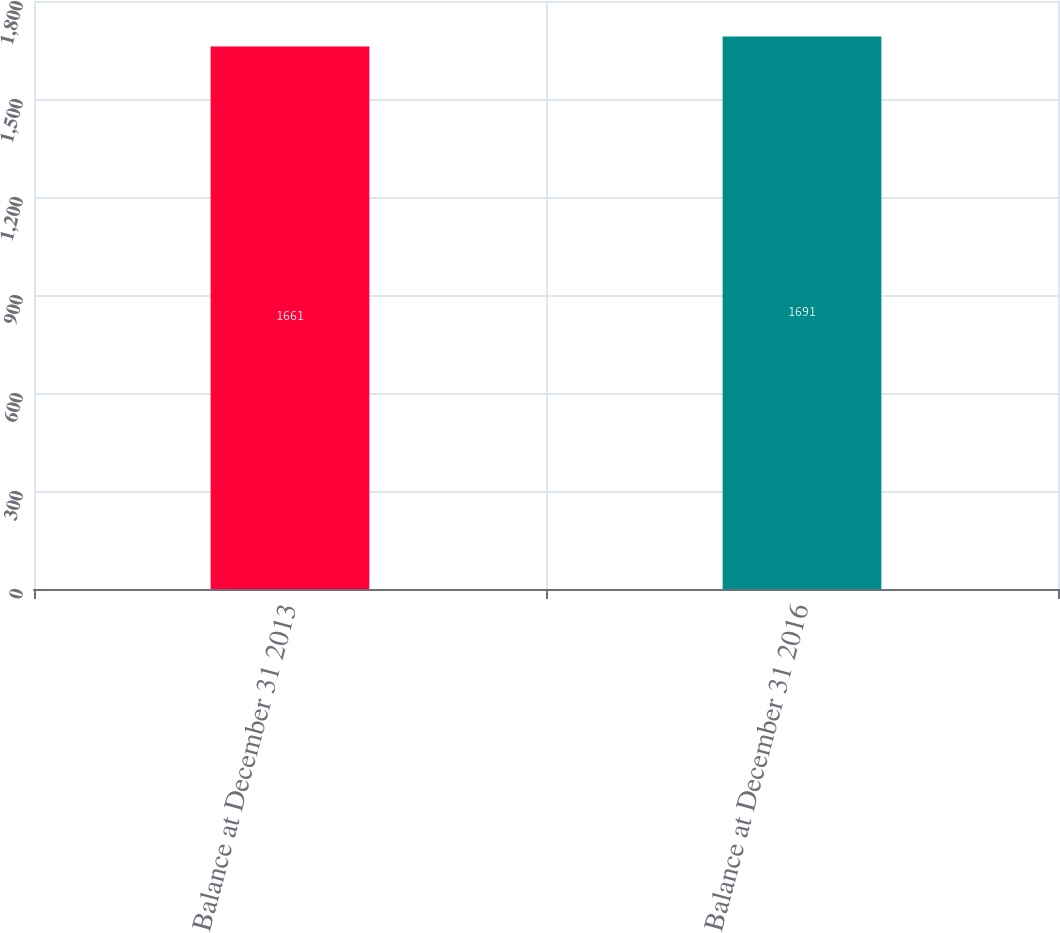<chart> <loc_0><loc_0><loc_500><loc_500><bar_chart><fcel>Balance at December 31 2013<fcel>Balance at December 31 2016<nl><fcel>1661<fcel>1691<nl></chart> 